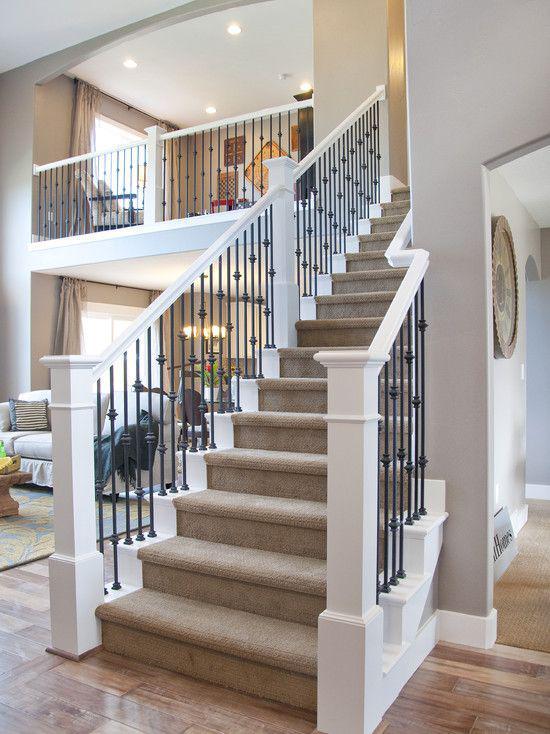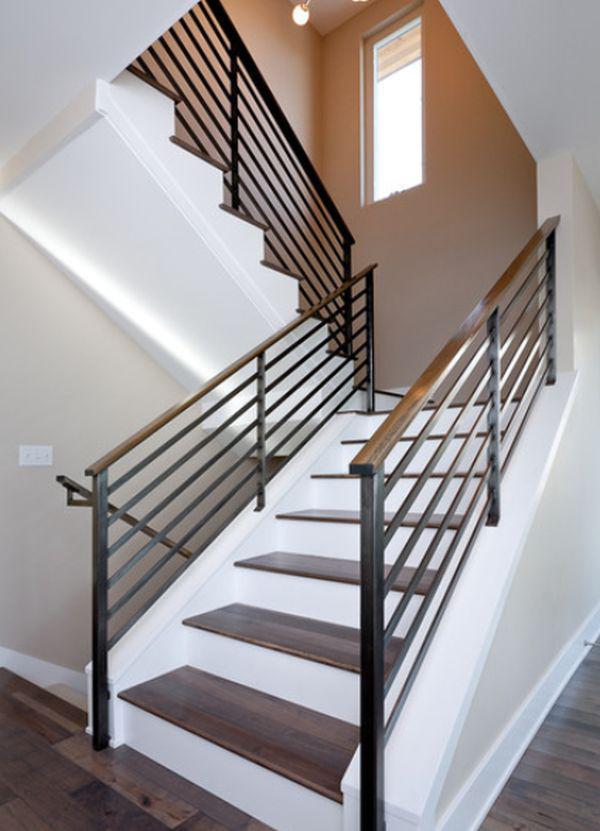The first image is the image on the left, the second image is the image on the right. Considering the images on both sides, is "At least one staircase that combines brown wood steps with white paint starts from the lower left angling rightward, then turns sharply back to the left." valid? Answer yes or no. Yes. 